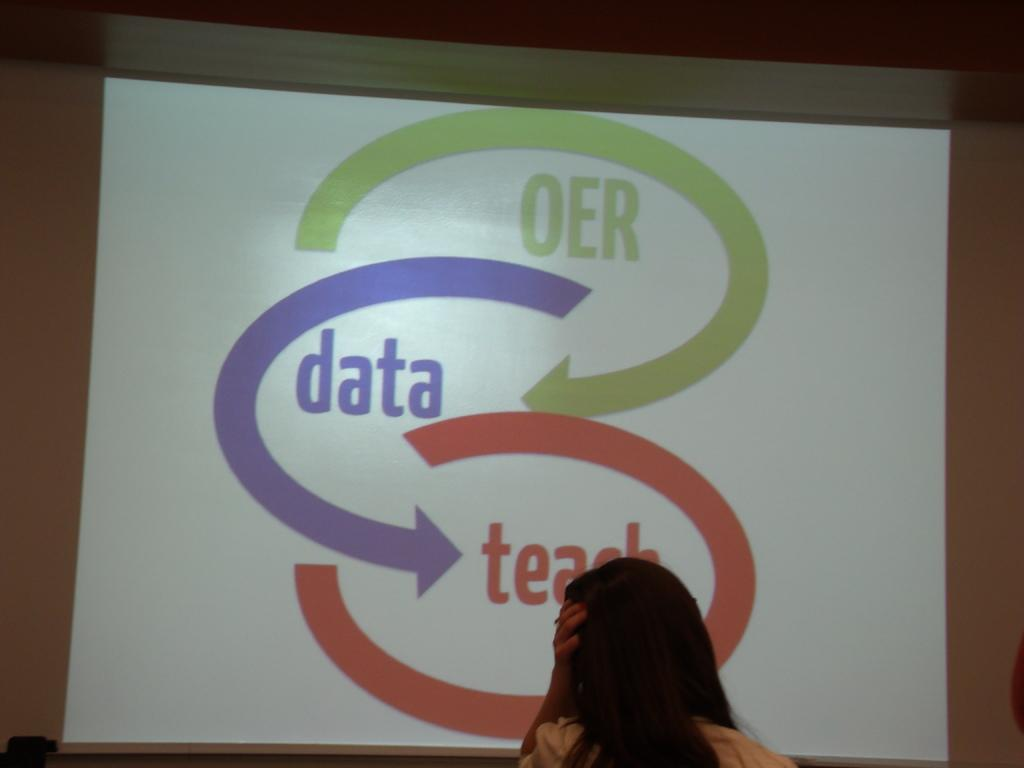What is present in the image? There is a person in the image. What can be seen in the background of the image? There is a screen in the background of the image. What is displayed on the screen? There is text visible on the screen. What type of vase is being used to perform an action in the image? There is no vase or action being performed in the image; it features a person and a screen with text. 